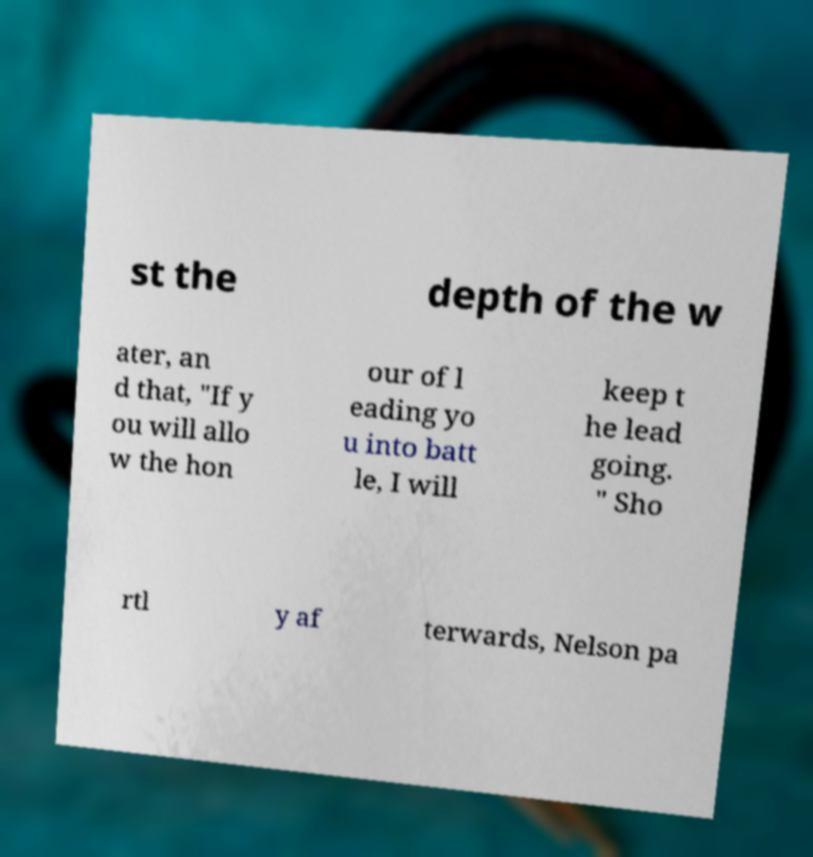Please identify and transcribe the text found in this image. st the depth of the w ater, an d that, "If y ou will allo w the hon our of l eading yo u into batt le, I will keep t he lead going. " Sho rtl y af terwards, Nelson pa 